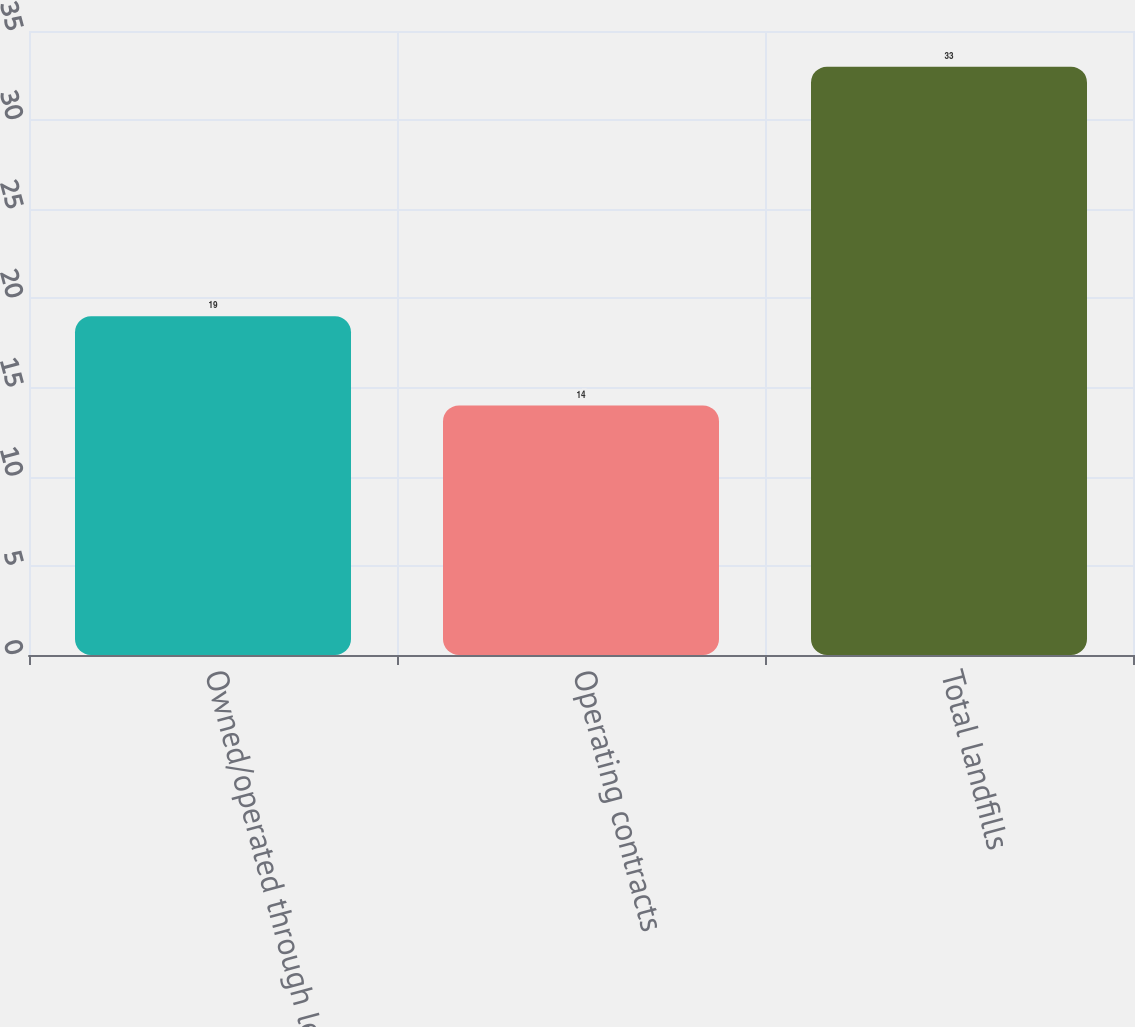<chart> <loc_0><loc_0><loc_500><loc_500><bar_chart><fcel>Owned/operated through lease<fcel>Operating contracts<fcel>Total landfills<nl><fcel>19<fcel>14<fcel>33<nl></chart> 